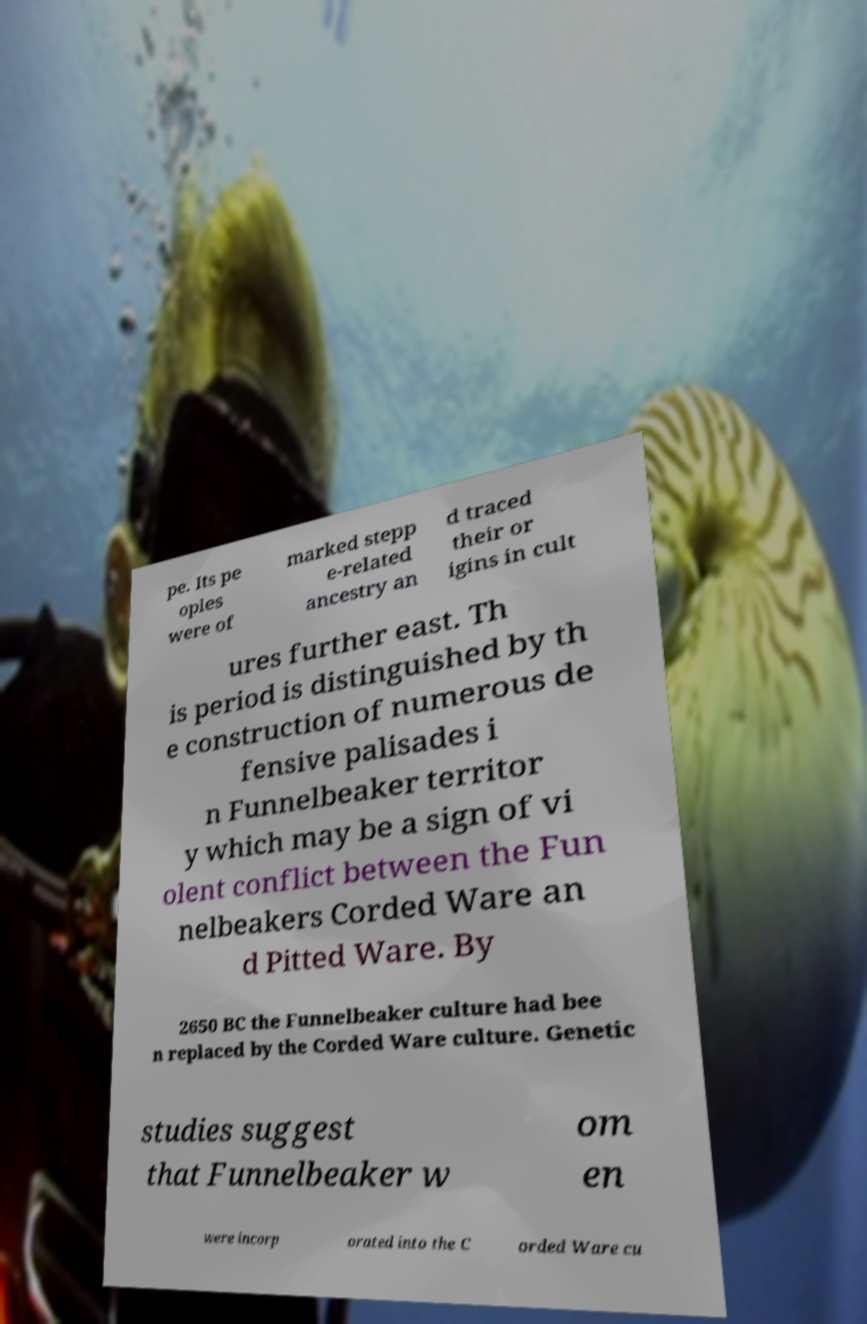I need the written content from this picture converted into text. Can you do that? pe. Its pe oples were of marked stepp e-related ancestry an d traced their or igins in cult ures further east. Th is period is distinguished by th e construction of numerous de fensive palisades i n Funnelbeaker territor y which may be a sign of vi olent conflict between the Fun nelbeakers Corded Ware an d Pitted Ware. By 2650 BC the Funnelbeaker culture had bee n replaced by the Corded Ware culture. Genetic studies suggest that Funnelbeaker w om en were incorp orated into the C orded Ware cu 